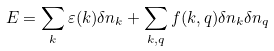<formula> <loc_0><loc_0><loc_500><loc_500>E = \sum _ { k } \varepsilon ( k ) \delta n _ { k } + \sum _ { k , q } f ( k , q ) \delta n _ { k } \delta n _ { q }</formula> 